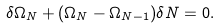Convert formula to latex. <formula><loc_0><loc_0><loc_500><loc_500>\delta \Omega _ { N } + ( \Omega _ { N } - \Omega _ { N - 1 } ) \delta N = 0 .</formula> 